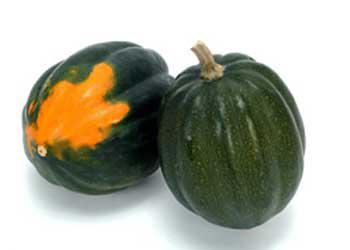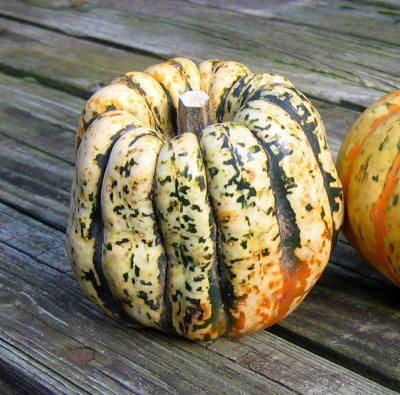The first image is the image on the left, the second image is the image on the right. Analyze the images presented: Is the assertion "The left image includes multiple squash with yellow tops and green variegated bottoms and does not include any solid colored squash." valid? Answer yes or no. No. The first image is the image on the left, the second image is the image on the right. Evaluate the accuracy of this statement regarding the images: "There are fewer than ten squashes.". Is it true? Answer yes or no. Yes. 